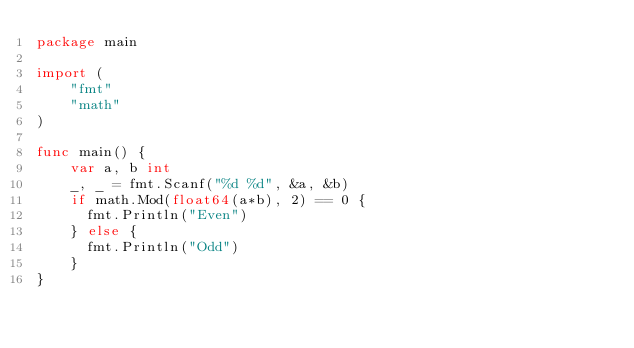<code> <loc_0><loc_0><loc_500><loc_500><_Go_>package main

import (
    "fmt"
    "math"
)

func main() {
    var a, b int
    _, _ = fmt.Scanf("%d %d", &a, &b)
    if math.Mod(float64(a*b), 2) == 0 {
      fmt.Println("Even")
    } else {
      fmt.Println("Odd")
    }
}</code> 